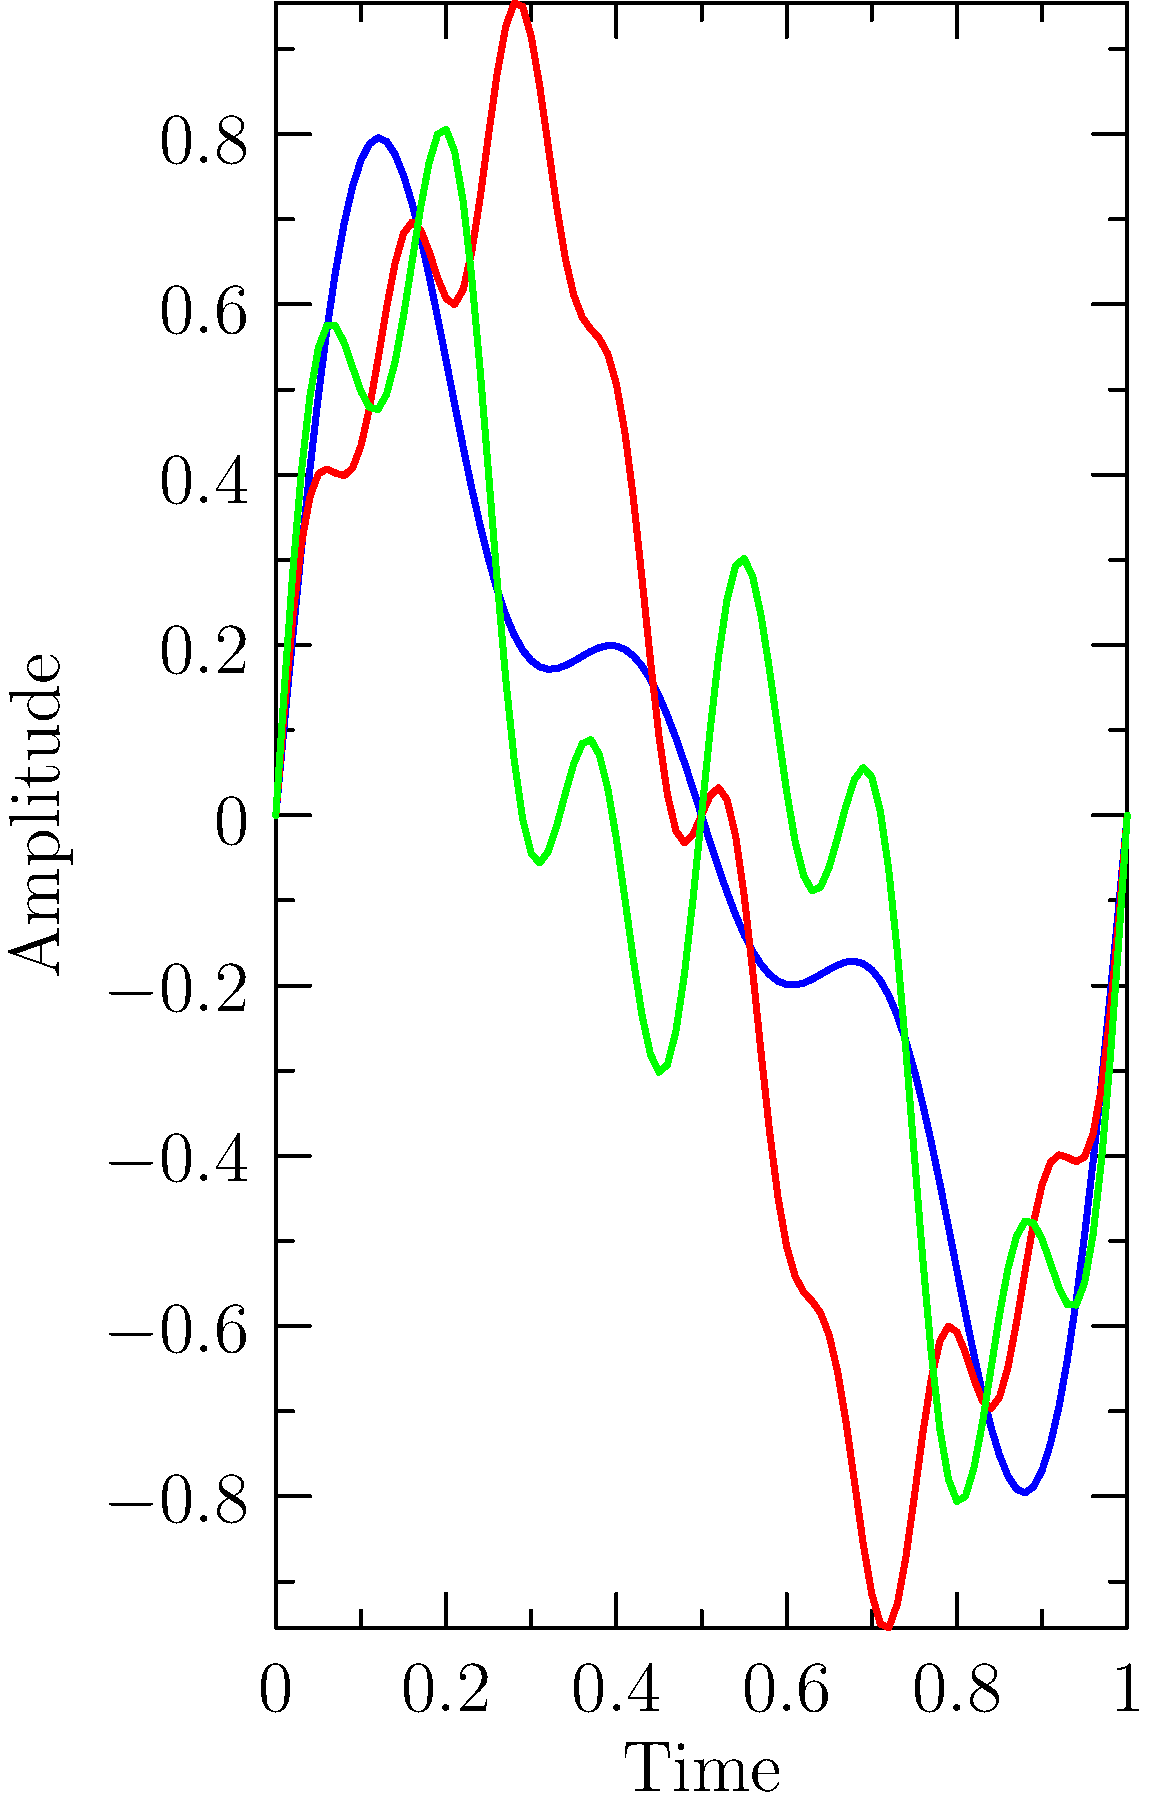Analyze the frequency spectra of the three musical genres represented by the waveforms in the graph. Which genre is most likely to represent a pop music track aimed at dominating the charts, and why? To answer this question, we need to analyze the characteristics of each waveform:

1. Genre A (Blue):
   - Has a mix of low, medium, and high frequencies
   - Relatively balanced distribution of energy across frequencies
   - Moderate complexity in the waveform

2. Genre B (Red):
   - Dominated by low frequencies (large, smooth waves)
   - Some high-frequency components (small ripples)
   - Overall simpler waveform compared to others

3. Genre C (Green):
   - Mix of low and medium frequencies
   - Some high-frequency components
   - Moderate complexity, but less balanced than Genre A

For a pop music track aimed at dominating the charts:

1. We want a strong bass presence for danceability, represented by low frequencies.
2. We need clear, catchy melodies in the mid-range frequencies.
3. Some high-frequency components add brightness and clarity to the mix.
4. The overall spectrum should be well-balanced for a polished, professional sound.

Genre B (Red) best fits these criteria:
- Strong low-frequency content for a powerful bass and beat
- Simpler waveform, indicating a more straightforward, catchy melody
- Presence of high-frequency components for clarity and brightness
- Overall spectral balance that's pleasing to the ear and suitable for mainstream appeal

This type of frequency spectrum is often associated with modern pop music that aims for chart success, as it provides a good balance of danceability, catchiness, and production polish.
Answer: Genre B (Red) 